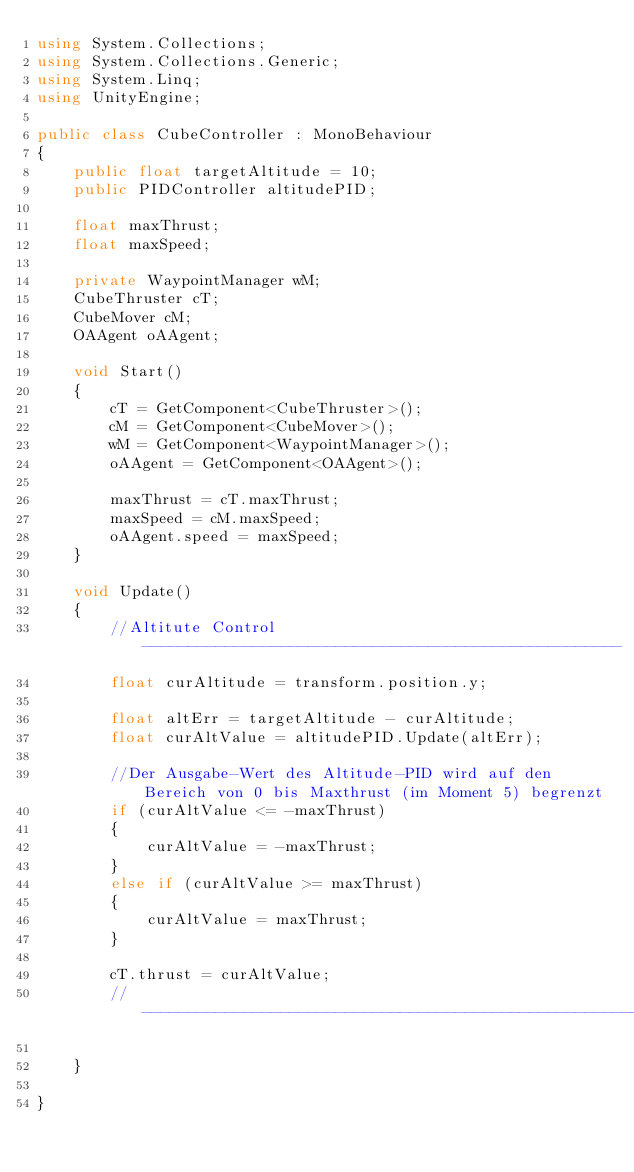Convert code to text. <code><loc_0><loc_0><loc_500><loc_500><_C#_>using System.Collections;
using System.Collections.Generic;
using System.Linq;
using UnityEngine;

public class CubeController : MonoBehaviour
{
    public float targetAltitude = 10;
    public PIDController altitudePID;

    float maxThrust;
    float maxSpeed;

    private WaypointManager wM;
    CubeThruster cT;
    CubeMover cM;
    OAAgent oAAgent;

    void Start()
    {
        cT = GetComponent<CubeThruster>();
        cM = GetComponent<CubeMover>();
        wM = GetComponent<WaypointManager>();
        oAAgent = GetComponent<OAAgent>();

        maxThrust = cT.maxThrust;
        maxSpeed = cM.maxSpeed;
        oAAgent.speed = maxSpeed;
    }

    void Update()
    {
        //Altitute Control ----------------------------------------------------
        float curAltitude = transform.position.y;

        float altErr = targetAltitude - curAltitude;
        float curAltValue = altitudePID.Update(altErr);

        //Der Ausgabe-Wert des Altitude-PID wird auf den Bereich von 0 bis Maxthrust (im Moment 5) begrenzt
        if (curAltValue <= -maxThrust)
        {
            curAltValue = -maxThrust;
        }
        else if (curAltValue >= maxThrust)
        {
            curAltValue = maxThrust;
        }

        cT.thrust = curAltValue;
        //---------------------------------------------------------------------

    }

}
</code> 